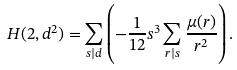Convert formula to latex. <formula><loc_0><loc_0><loc_500><loc_500>H ( 2 , d ^ { 2 } ) = \sum _ { s | d } \left ( - \frac { 1 } { 1 2 } s ^ { 3 } \sum _ { r | s } \frac { \mu ( r ) } { r ^ { 2 } } \right ) .</formula> 